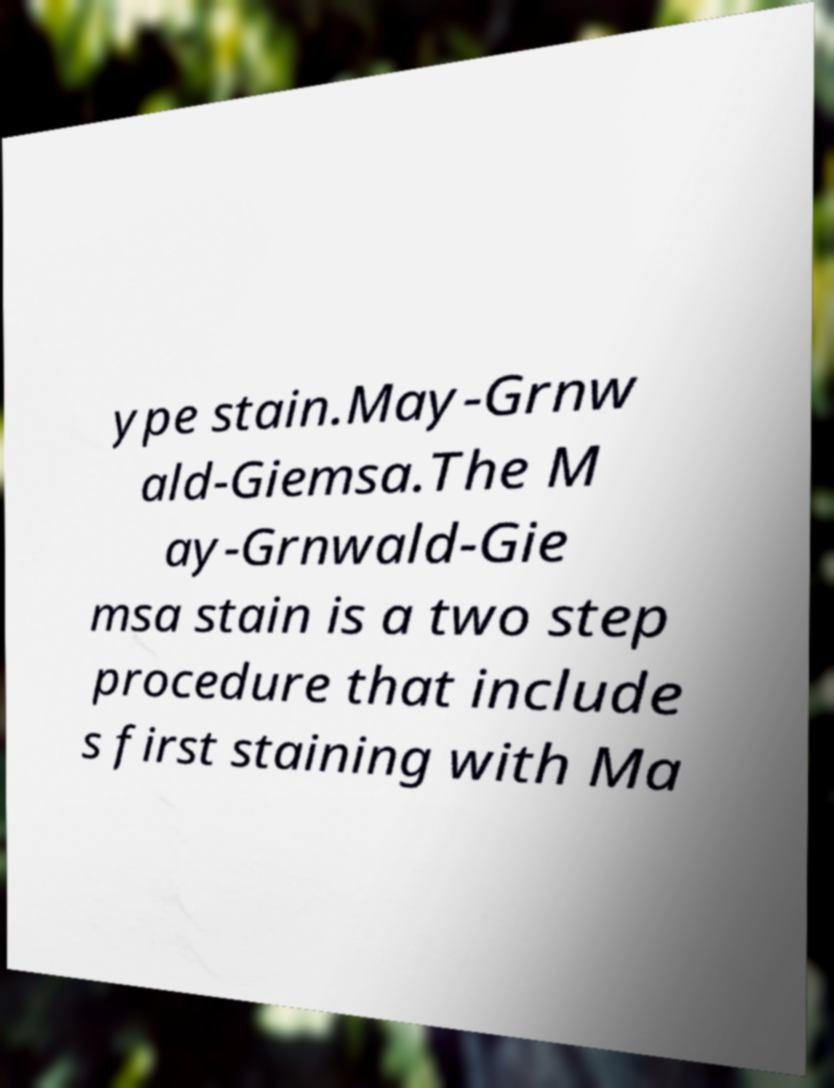What messages or text are displayed in this image? I need them in a readable, typed format. ype stain.May-Grnw ald-Giemsa.The M ay-Grnwald-Gie msa stain is a two step procedure that include s first staining with Ma 